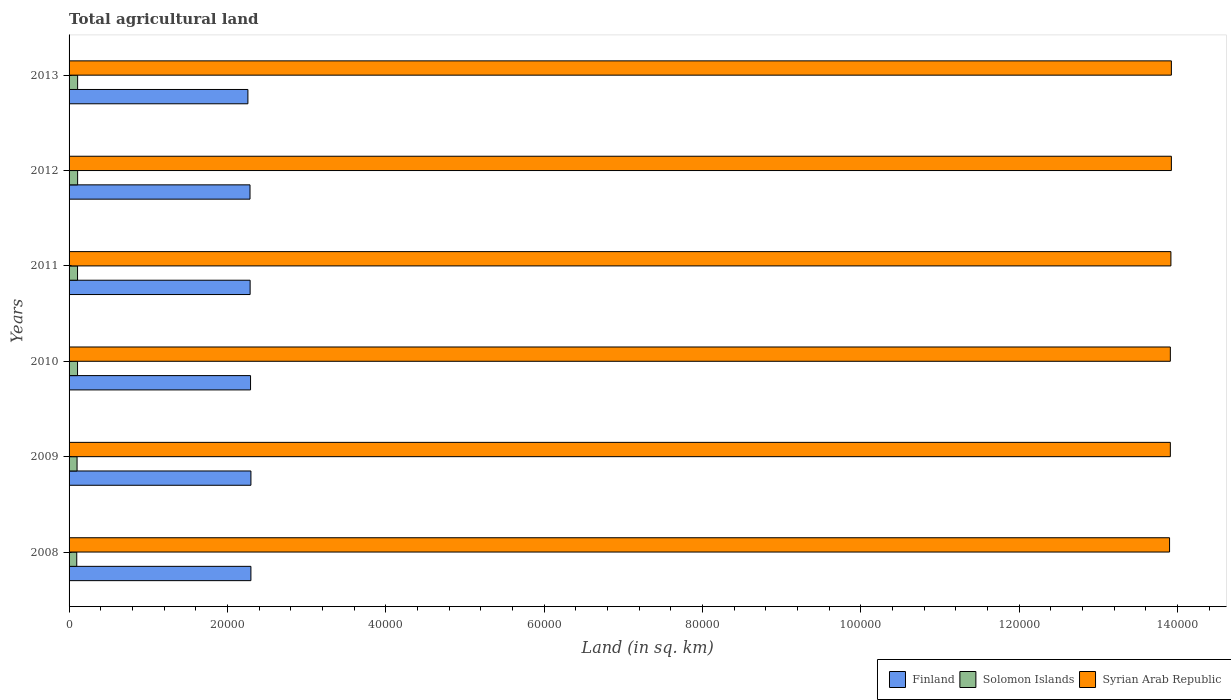How many different coloured bars are there?
Your answer should be very brief. 3. How many groups of bars are there?
Your answer should be compact. 6. Are the number of bars on each tick of the Y-axis equal?
Your response must be concise. Yes. What is the total agricultural land in Finland in 2013?
Make the answer very short. 2.26e+04. Across all years, what is the maximum total agricultural land in Finland?
Your response must be concise. 2.30e+04. Across all years, what is the minimum total agricultural land in Syrian Arab Republic?
Provide a short and direct response. 1.39e+05. In which year was the total agricultural land in Finland maximum?
Make the answer very short. 2009. What is the total total agricultural land in Syrian Arab Republic in the graph?
Keep it short and to the point. 8.35e+05. What is the difference between the total agricultural land in Finland in 2009 and that in 2011?
Offer a terse response. 99. What is the difference between the total agricultural land in Finland in 2010 and the total agricultural land in Solomon Islands in 2013?
Offer a terse response. 2.18e+04. What is the average total agricultural land in Syrian Arab Republic per year?
Make the answer very short. 1.39e+05. In the year 2012, what is the difference between the total agricultural land in Syrian Arab Republic and total agricultural land in Solomon Islands?
Provide a succinct answer. 1.38e+05. What is the ratio of the total agricultural land in Finland in 2010 to that in 2012?
Provide a succinct answer. 1. Is the total agricultural land in Solomon Islands in 2008 less than that in 2011?
Your response must be concise. Yes. What is the difference between the highest and the lowest total agricultural land in Finland?
Offer a very short reply. 380. In how many years, is the total agricultural land in Syrian Arab Republic greater than the average total agricultural land in Syrian Arab Republic taken over all years?
Give a very brief answer. 3. Is the sum of the total agricultural land in Syrian Arab Republic in 2009 and 2010 greater than the maximum total agricultural land in Finland across all years?
Provide a succinct answer. Yes. What does the 1st bar from the top in 2010 represents?
Ensure brevity in your answer.  Syrian Arab Republic. What does the 3rd bar from the bottom in 2009 represents?
Your response must be concise. Syrian Arab Republic. Are all the bars in the graph horizontal?
Your answer should be compact. Yes. What is the difference between two consecutive major ticks on the X-axis?
Give a very brief answer. 2.00e+04. Are the values on the major ticks of X-axis written in scientific E-notation?
Keep it short and to the point. No. How many legend labels are there?
Make the answer very short. 3. What is the title of the graph?
Ensure brevity in your answer.  Total agricultural land. What is the label or title of the X-axis?
Give a very brief answer. Land (in sq. km). What is the Land (in sq. km) of Finland in 2008?
Your response must be concise. 2.30e+04. What is the Land (in sq. km) of Solomon Islands in 2008?
Offer a terse response. 970. What is the Land (in sq. km) in Syrian Arab Republic in 2008?
Provide a succinct answer. 1.39e+05. What is the Land (in sq. km) of Finland in 2009?
Provide a succinct answer. 2.30e+04. What is the Land (in sq. km) in Solomon Islands in 2009?
Ensure brevity in your answer.  1010. What is the Land (in sq. km) of Syrian Arab Republic in 2009?
Provide a short and direct response. 1.39e+05. What is the Land (in sq. km) of Finland in 2010?
Your answer should be very brief. 2.29e+04. What is the Land (in sq. km) in Solomon Islands in 2010?
Provide a succinct answer. 1070. What is the Land (in sq. km) of Syrian Arab Republic in 2010?
Your response must be concise. 1.39e+05. What is the Land (in sq. km) in Finland in 2011?
Your answer should be very brief. 2.29e+04. What is the Land (in sq. km) in Solomon Islands in 2011?
Provide a short and direct response. 1070. What is the Land (in sq. km) of Syrian Arab Republic in 2011?
Provide a short and direct response. 1.39e+05. What is the Land (in sq. km) in Finland in 2012?
Your response must be concise. 2.29e+04. What is the Land (in sq. km) of Solomon Islands in 2012?
Keep it short and to the point. 1080. What is the Land (in sq. km) in Syrian Arab Republic in 2012?
Your answer should be very brief. 1.39e+05. What is the Land (in sq. km) in Finland in 2013?
Provide a short and direct response. 2.26e+04. What is the Land (in sq. km) in Solomon Islands in 2013?
Your response must be concise. 1080. What is the Land (in sq. km) in Syrian Arab Republic in 2013?
Provide a succinct answer. 1.39e+05. Across all years, what is the maximum Land (in sq. km) of Finland?
Offer a terse response. 2.30e+04. Across all years, what is the maximum Land (in sq. km) in Solomon Islands?
Offer a terse response. 1080. Across all years, what is the maximum Land (in sq. km) in Syrian Arab Republic?
Offer a terse response. 1.39e+05. Across all years, what is the minimum Land (in sq. km) of Finland?
Your answer should be compact. 2.26e+04. Across all years, what is the minimum Land (in sq. km) of Solomon Islands?
Keep it short and to the point. 970. Across all years, what is the minimum Land (in sq. km) of Syrian Arab Republic?
Your response must be concise. 1.39e+05. What is the total Land (in sq. km) of Finland in the graph?
Keep it short and to the point. 1.37e+05. What is the total Land (in sq. km) in Solomon Islands in the graph?
Your answer should be very brief. 6280. What is the total Land (in sq. km) of Syrian Arab Republic in the graph?
Ensure brevity in your answer.  8.35e+05. What is the difference between the Land (in sq. km) of Finland in 2008 and that in 2009?
Give a very brief answer. -1. What is the difference between the Land (in sq. km) of Syrian Arab Republic in 2008 and that in 2009?
Your answer should be very brief. -100. What is the difference between the Land (in sq. km) in Solomon Islands in 2008 and that in 2010?
Ensure brevity in your answer.  -100. What is the difference between the Land (in sq. km) of Syrian Arab Republic in 2008 and that in 2010?
Ensure brevity in your answer.  -100. What is the difference between the Land (in sq. km) of Solomon Islands in 2008 and that in 2011?
Provide a succinct answer. -100. What is the difference between the Land (in sq. km) of Syrian Arab Republic in 2008 and that in 2011?
Your answer should be very brief. -170. What is the difference between the Land (in sq. km) in Finland in 2008 and that in 2012?
Give a very brief answer. 113. What is the difference between the Land (in sq. km) in Solomon Islands in 2008 and that in 2012?
Offer a very short reply. -110. What is the difference between the Land (in sq. km) of Syrian Arab Republic in 2008 and that in 2012?
Ensure brevity in your answer.  -230. What is the difference between the Land (in sq. km) of Finland in 2008 and that in 2013?
Your answer should be very brief. 379. What is the difference between the Land (in sq. km) in Solomon Islands in 2008 and that in 2013?
Give a very brief answer. -110. What is the difference between the Land (in sq. km) of Syrian Arab Republic in 2008 and that in 2013?
Your response must be concise. -230. What is the difference between the Land (in sq. km) in Finland in 2009 and that in 2010?
Ensure brevity in your answer.  46. What is the difference between the Land (in sq. km) in Solomon Islands in 2009 and that in 2010?
Keep it short and to the point. -60. What is the difference between the Land (in sq. km) of Finland in 2009 and that in 2011?
Offer a terse response. 99. What is the difference between the Land (in sq. km) in Solomon Islands in 2009 and that in 2011?
Your answer should be compact. -60. What is the difference between the Land (in sq. km) of Syrian Arab Republic in 2009 and that in 2011?
Your answer should be very brief. -70. What is the difference between the Land (in sq. km) of Finland in 2009 and that in 2012?
Offer a very short reply. 114. What is the difference between the Land (in sq. km) in Solomon Islands in 2009 and that in 2012?
Provide a succinct answer. -70. What is the difference between the Land (in sq. km) in Syrian Arab Republic in 2009 and that in 2012?
Provide a short and direct response. -130. What is the difference between the Land (in sq. km) in Finland in 2009 and that in 2013?
Give a very brief answer. 380. What is the difference between the Land (in sq. km) in Solomon Islands in 2009 and that in 2013?
Ensure brevity in your answer.  -70. What is the difference between the Land (in sq. km) in Syrian Arab Republic in 2009 and that in 2013?
Offer a terse response. -130. What is the difference between the Land (in sq. km) of Syrian Arab Republic in 2010 and that in 2011?
Provide a succinct answer. -70. What is the difference between the Land (in sq. km) in Finland in 2010 and that in 2012?
Provide a short and direct response. 68. What is the difference between the Land (in sq. km) in Solomon Islands in 2010 and that in 2012?
Your answer should be very brief. -10. What is the difference between the Land (in sq. km) of Syrian Arab Republic in 2010 and that in 2012?
Provide a short and direct response. -130. What is the difference between the Land (in sq. km) of Finland in 2010 and that in 2013?
Make the answer very short. 334. What is the difference between the Land (in sq. km) of Solomon Islands in 2010 and that in 2013?
Keep it short and to the point. -10. What is the difference between the Land (in sq. km) in Syrian Arab Republic in 2010 and that in 2013?
Ensure brevity in your answer.  -130. What is the difference between the Land (in sq. km) of Finland in 2011 and that in 2012?
Offer a very short reply. 15. What is the difference between the Land (in sq. km) of Solomon Islands in 2011 and that in 2012?
Your answer should be very brief. -10. What is the difference between the Land (in sq. km) in Syrian Arab Republic in 2011 and that in 2012?
Offer a terse response. -60. What is the difference between the Land (in sq. km) of Finland in 2011 and that in 2013?
Your answer should be compact. 281. What is the difference between the Land (in sq. km) in Solomon Islands in 2011 and that in 2013?
Make the answer very short. -10. What is the difference between the Land (in sq. km) of Syrian Arab Republic in 2011 and that in 2013?
Your answer should be very brief. -60. What is the difference between the Land (in sq. km) of Finland in 2012 and that in 2013?
Provide a short and direct response. 266. What is the difference between the Land (in sq. km) of Solomon Islands in 2012 and that in 2013?
Give a very brief answer. 0. What is the difference between the Land (in sq. km) in Finland in 2008 and the Land (in sq. km) in Solomon Islands in 2009?
Offer a terse response. 2.20e+04. What is the difference between the Land (in sq. km) of Finland in 2008 and the Land (in sq. km) of Syrian Arab Republic in 2009?
Make the answer very short. -1.16e+05. What is the difference between the Land (in sq. km) in Solomon Islands in 2008 and the Land (in sq. km) in Syrian Arab Republic in 2009?
Offer a terse response. -1.38e+05. What is the difference between the Land (in sq. km) in Finland in 2008 and the Land (in sq. km) in Solomon Islands in 2010?
Offer a very short reply. 2.19e+04. What is the difference between the Land (in sq. km) in Finland in 2008 and the Land (in sq. km) in Syrian Arab Republic in 2010?
Ensure brevity in your answer.  -1.16e+05. What is the difference between the Land (in sq. km) of Solomon Islands in 2008 and the Land (in sq. km) of Syrian Arab Republic in 2010?
Provide a succinct answer. -1.38e+05. What is the difference between the Land (in sq. km) of Finland in 2008 and the Land (in sq. km) of Solomon Islands in 2011?
Give a very brief answer. 2.19e+04. What is the difference between the Land (in sq. km) in Finland in 2008 and the Land (in sq. km) in Syrian Arab Republic in 2011?
Your answer should be compact. -1.16e+05. What is the difference between the Land (in sq. km) of Solomon Islands in 2008 and the Land (in sq. km) of Syrian Arab Republic in 2011?
Your answer should be compact. -1.38e+05. What is the difference between the Land (in sq. km) in Finland in 2008 and the Land (in sq. km) in Solomon Islands in 2012?
Provide a succinct answer. 2.19e+04. What is the difference between the Land (in sq. km) of Finland in 2008 and the Land (in sq. km) of Syrian Arab Republic in 2012?
Offer a terse response. -1.16e+05. What is the difference between the Land (in sq. km) in Solomon Islands in 2008 and the Land (in sq. km) in Syrian Arab Republic in 2012?
Keep it short and to the point. -1.38e+05. What is the difference between the Land (in sq. km) of Finland in 2008 and the Land (in sq. km) of Solomon Islands in 2013?
Make the answer very short. 2.19e+04. What is the difference between the Land (in sq. km) of Finland in 2008 and the Land (in sq. km) of Syrian Arab Republic in 2013?
Offer a terse response. -1.16e+05. What is the difference between the Land (in sq. km) of Solomon Islands in 2008 and the Land (in sq. km) of Syrian Arab Republic in 2013?
Keep it short and to the point. -1.38e+05. What is the difference between the Land (in sq. km) of Finland in 2009 and the Land (in sq. km) of Solomon Islands in 2010?
Offer a terse response. 2.19e+04. What is the difference between the Land (in sq. km) in Finland in 2009 and the Land (in sq. km) in Syrian Arab Republic in 2010?
Keep it short and to the point. -1.16e+05. What is the difference between the Land (in sq. km) in Solomon Islands in 2009 and the Land (in sq. km) in Syrian Arab Republic in 2010?
Your answer should be very brief. -1.38e+05. What is the difference between the Land (in sq. km) of Finland in 2009 and the Land (in sq. km) of Solomon Islands in 2011?
Offer a very short reply. 2.19e+04. What is the difference between the Land (in sq. km) in Finland in 2009 and the Land (in sq. km) in Syrian Arab Republic in 2011?
Your response must be concise. -1.16e+05. What is the difference between the Land (in sq. km) in Solomon Islands in 2009 and the Land (in sq. km) in Syrian Arab Republic in 2011?
Keep it short and to the point. -1.38e+05. What is the difference between the Land (in sq. km) in Finland in 2009 and the Land (in sq. km) in Solomon Islands in 2012?
Offer a very short reply. 2.19e+04. What is the difference between the Land (in sq. km) of Finland in 2009 and the Land (in sq. km) of Syrian Arab Republic in 2012?
Offer a very short reply. -1.16e+05. What is the difference between the Land (in sq. km) in Solomon Islands in 2009 and the Land (in sq. km) in Syrian Arab Republic in 2012?
Offer a terse response. -1.38e+05. What is the difference between the Land (in sq. km) of Finland in 2009 and the Land (in sq. km) of Solomon Islands in 2013?
Provide a short and direct response. 2.19e+04. What is the difference between the Land (in sq. km) of Finland in 2009 and the Land (in sq. km) of Syrian Arab Republic in 2013?
Your answer should be very brief. -1.16e+05. What is the difference between the Land (in sq. km) of Solomon Islands in 2009 and the Land (in sq. km) of Syrian Arab Republic in 2013?
Provide a short and direct response. -1.38e+05. What is the difference between the Land (in sq. km) in Finland in 2010 and the Land (in sq. km) in Solomon Islands in 2011?
Keep it short and to the point. 2.18e+04. What is the difference between the Land (in sq. km) of Finland in 2010 and the Land (in sq. km) of Syrian Arab Republic in 2011?
Your answer should be compact. -1.16e+05. What is the difference between the Land (in sq. km) of Solomon Islands in 2010 and the Land (in sq. km) of Syrian Arab Republic in 2011?
Your response must be concise. -1.38e+05. What is the difference between the Land (in sq. km) of Finland in 2010 and the Land (in sq. km) of Solomon Islands in 2012?
Ensure brevity in your answer.  2.18e+04. What is the difference between the Land (in sq. km) in Finland in 2010 and the Land (in sq. km) in Syrian Arab Republic in 2012?
Keep it short and to the point. -1.16e+05. What is the difference between the Land (in sq. km) of Solomon Islands in 2010 and the Land (in sq. km) of Syrian Arab Republic in 2012?
Keep it short and to the point. -1.38e+05. What is the difference between the Land (in sq. km) of Finland in 2010 and the Land (in sq. km) of Solomon Islands in 2013?
Your response must be concise. 2.18e+04. What is the difference between the Land (in sq. km) of Finland in 2010 and the Land (in sq. km) of Syrian Arab Republic in 2013?
Your answer should be compact. -1.16e+05. What is the difference between the Land (in sq. km) in Solomon Islands in 2010 and the Land (in sq. km) in Syrian Arab Republic in 2013?
Offer a terse response. -1.38e+05. What is the difference between the Land (in sq. km) of Finland in 2011 and the Land (in sq. km) of Solomon Islands in 2012?
Provide a short and direct response. 2.18e+04. What is the difference between the Land (in sq. km) in Finland in 2011 and the Land (in sq. km) in Syrian Arab Republic in 2012?
Your answer should be compact. -1.16e+05. What is the difference between the Land (in sq. km) of Solomon Islands in 2011 and the Land (in sq. km) of Syrian Arab Republic in 2012?
Provide a succinct answer. -1.38e+05. What is the difference between the Land (in sq. km) of Finland in 2011 and the Land (in sq. km) of Solomon Islands in 2013?
Offer a very short reply. 2.18e+04. What is the difference between the Land (in sq. km) in Finland in 2011 and the Land (in sq. km) in Syrian Arab Republic in 2013?
Keep it short and to the point. -1.16e+05. What is the difference between the Land (in sq. km) of Solomon Islands in 2011 and the Land (in sq. km) of Syrian Arab Republic in 2013?
Your answer should be very brief. -1.38e+05. What is the difference between the Land (in sq. km) in Finland in 2012 and the Land (in sq. km) in Solomon Islands in 2013?
Offer a terse response. 2.18e+04. What is the difference between the Land (in sq. km) in Finland in 2012 and the Land (in sq. km) in Syrian Arab Republic in 2013?
Provide a succinct answer. -1.16e+05. What is the difference between the Land (in sq. km) of Solomon Islands in 2012 and the Land (in sq. km) of Syrian Arab Republic in 2013?
Offer a terse response. -1.38e+05. What is the average Land (in sq. km) of Finland per year?
Your answer should be compact. 2.29e+04. What is the average Land (in sq. km) in Solomon Islands per year?
Give a very brief answer. 1046.67. What is the average Land (in sq. km) in Syrian Arab Republic per year?
Give a very brief answer. 1.39e+05. In the year 2008, what is the difference between the Land (in sq. km) in Finland and Land (in sq. km) in Solomon Islands?
Give a very brief answer. 2.20e+04. In the year 2008, what is the difference between the Land (in sq. km) of Finland and Land (in sq. km) of Syrian Arab Republic?
Offer a terse response. -1.16e+05. In the year 2008, what is the difference between the Land (in sq. km) of Solomon Islands and Land (in sq. km) of Syrian Arab Republic?
Ensure brevity in your answer.  -1.38e+05. In the year 2009, what is the difference between the Land (in sq. km) in Finland and Land (in sq. km) in Solomon Islands?
Offer a terse response. 2.20e+04. In the year 2009, what is the difference between the Land (in sq. km) of Finland and Land (in sq. km) of Syrian Arab Republic?
Your response must be concise. -1.16e+05. In the year 2009, what is the difference between the Land (in sq. km) in Solomon Islands and Land (in sq. km) in Syrian Arab Republic?
Offer a terse response. -1.38e+05. In the year 2010, what is the difference between the Land (in sq. km) of Finland and Land (in sq. km) of Solomon Islands?
Your response must be concise. 2.18e+04. In the year 2010, what is the difference between the Land (in sq. km) of Finland and Land (in sq. km) of Syrian Arab Republic?
Provide a succinct answer. -1.16e+05. In the year 2010, what is the difference between the Land (in sq. km) of Solomon Islands and Land (in sq. km) of Syrian Arab Republic?
Your answer should be compact. -1.38e+05. In the year 2011, what is the difference between the Land (in sq. km) of Finland and Land (in sq. km) of Solomon Islands?
Offer a terse response. 2.18e+04. In the year 2011, what is the difference between the Land (in sq. km) of Finland and Land (in sq. km) of Syrian Arab Republic?
Make the answer very short. -1.16e+05. In the year 2011, what is the difference between the Land (in sq. km) in Solomon Islands and Land (in sq. km) in Syrian Arab Republic?
Make the answer very short. -1.38e+05. In the year 2012, what is the difference between the Land (in sq. km) in Finland and Land (in sq. km) in Solomon Islands?
Offer a very short reply. 2.18e+04. In the year 2012, what is the difference between the Land (in sq. km) in Finland and Land (in sq. km) in Syrian Arab Republic?
Your response must be concise. -1.16e+05. In the year 2012, what is the difference between the Land (in sq. km) in Solomon Islands and Land (in sq. km) in Syrian Arab Republic?
Provide a succinct answer. -1.38e+05. In the year 2013, what is the difference between the Land (in sq. km) of Finland and Land (in sq. km) of Solomon Islands?
Give a very brief answer. 2.15e+04. In the year 2013, what is the difference between the Land (in sq. km) of Finland and Land (in sq. km) of Syrian Arab Republic?
Provide a short and direct response. -1.17e+05. In the year 2013, what is the difference between the Land (in sq. km) in Solomon Islands and Land (in sq. km) in Syrian Arab Republic?
Offer a terse response. -1.38e+05. What is the ratio of the Land (in sq. km) of Solomon Islands in 2008 to that in 2009?
Provide a succinct answer. 0.96. What is the ratio of the Land (in sq. km) in Solomon Islands in 2008 to that in 2010?
Offer a very short reply. 0.91. What is the ratio of the Land (in sq. km) in Syrian Arab Republic in 2008 to that in 2010?
Offer a terse response. 1. What is the ratio of the Land (in sq. km) in Finland in 2008 to that in 2011?
Make the answer very short. 1. What is the ratio of the Land (in sq. km) in Solomon Islands in 2008 to that in 2011?
Provide a short and direct response. 0.91. What is the ratio of the Land (in sq. km) in Syrian Arab Republic in 2008 to that in 2011?
Keep it short and to the point. 1. What is the ratio of the Land (in sq. km) in Finland in 2008 to that in 2012?
Offer a very short reply. 1. What is the ratio of the Land (in sq. km) of Solomon Islands in 2008 to that in 2012?
Your response must be concise. 0.9. What is the ratio of the Land (in sq. km) of Syrian Arab Republic in 2008 to that in 2012?
Ensure brevity in your answer.  1. What is the ratio of the Land (in sq. km) of Finland in 2008 to that in 2013?
Provide a succinct answer. 1.02. What is the ratio of the Land (in sq. km) of Solomon Islands in 2008 to that in 2013?
Make the answer very short. 0.9. What is the ratio of the Land (in sq. km) in Solomon Islands in 2009 to that in 2010?
Make the answer very short. 0.94. What is the ratio of the Land (in sq. km) of Solomon Islands in 2009 to that in 2011?
Provide a succinct answer. 0.94. What is the ratio of the Land (in sq. km) in Syrian Arab Republic in 2009 to that in 2011?
Offer a terse response. 1. What is the ratio of the Land (in sq. km) of Finland in 2009 to that in 2012?
Your answer should be very brief. 1. What is the ratio of the Land (in sq. km) in Solomon Islands in 2009 to that in 2012?
Offer a very short reply. 0.94. What is the ratio of the Land (in sq. km) of Syrian Arab Republic in 2009 to that in 2012?
Your answer should be very brief. 1. What is the ratio of the Land (in sq. km) of Finland in 2009 to that in 2013?
Give a very brief answer. 1.02. What is the ratio of the Land (in sq. km) in Solomon Islands in 2009 to that in 2013?
Make the answer very short. 0.94. What is the ratio of the Land (in sq. km) of Syrian Arab Republic in 2009 to that in 2013?
Give a very brief answer. 1. What is the ratio of the Land (in sq. km) in Finland in 2010 to that in 2011?
Give a very brief answer. 1. What is the ratio of the Land (in sq. km) of Solomon Islands in 2010 to that in 2011?
Give a very brief answer. 1. What is the ratio of the Land (in sq. km) in Finland in 2010 to that in 2012?
Offer a very short reply. 1. What is the ratio of the Land (in sq. km) of Solomon Islands in 2010 to that in 2012?
Keep it short and to the point. 0.99. What is the ratio of the Land (in sq. km) of Syrian Arab Republic in 2010 to that in 2012?
Keep it short and to the point. 1. What is the ratio of the Land (in sq. km) of Finland in 2010 to that in 2013?
Give a very brief answer. 1.01. What is the ratio of the Land (in sq. km) in Solomon Islands in 2010 to that in 2013?
Offer a terse response. 0.99. What is the ratio of the Land (in sq. km) of Finland in 2011 to that in 2012?
Give a very brief answer. 1. What is the ratio of the Land (in sq. km) in Finland in 2011 to that in 2013?
Offer a very short reply. 1.01. What is the ratio of the Land (in sq. km) of Finland in 2012 to that in 2013?
Offer a very short reply. 1.01. What is the ratio of the Land (in sq. km) in Syrian Arab Republic in 2012 to that in 2013?
Your answer should be very brief. 1. What is the difference between the highest and the second highest Land (in sq. km) in Solomon Islands?
Your answer should be very brief. 0. What is the difference between the highest and the lowest Land (in sq. km) in Finland?
Keep it short and to the point. 380. What is the difference between the highest and the lowest Land (in sq. km) of Solomon Islands?
Give a very brief answer. 110. What is the difference between the highest and the lowest Land (in sq. km) of Syrian Arab Republic?
Your answer should be compact. 230. 